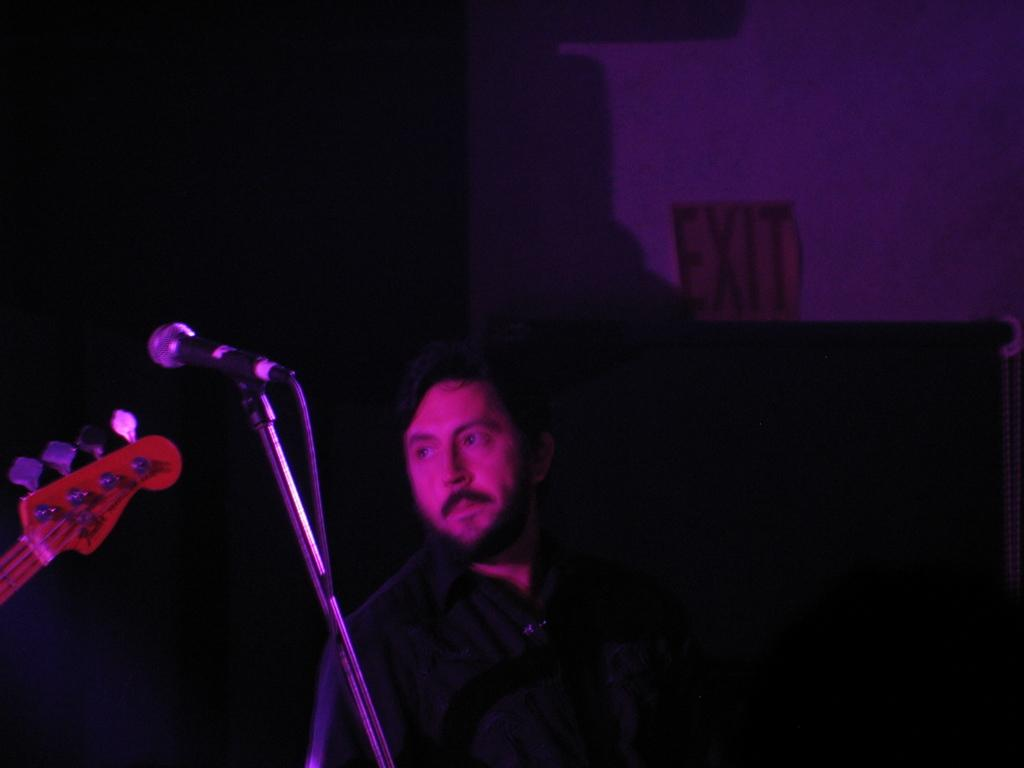What is the lighting condition in the image? The photo is taken in a dark room. Who is present in the image? There is a man in the image. What is the man wearing? The man is wearing a black shirt. What is the man doing in the image? The man is standing. What objects can be seen in the image related to music? There is a microphone and a musical instrument in the image. What type of sofa is visible in the image? There is no sofa present in the image. What cast member from a popular TV show is playing the musical instrument in the image? There is no cast member or TV show mentioned in the image; it only shows a man, a microphone, and a musical instrument. 